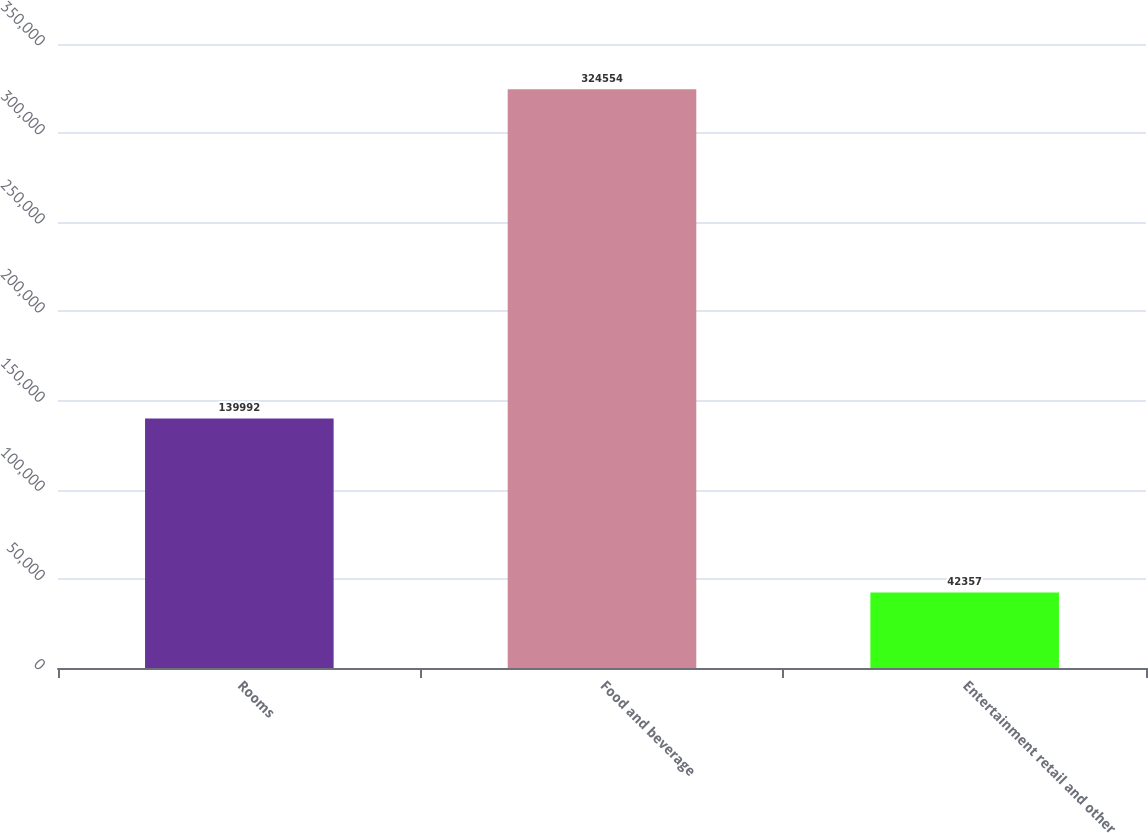Convert chart. <chart><loc_0><loc_0><loc_500><loc_500><bar_chart><fcel>Rooms<fcel>Food and beverage<fcel>Entertainment retail and other<nl><fcel>139992<fcel>324554<fcel>42357<nl></chart> 